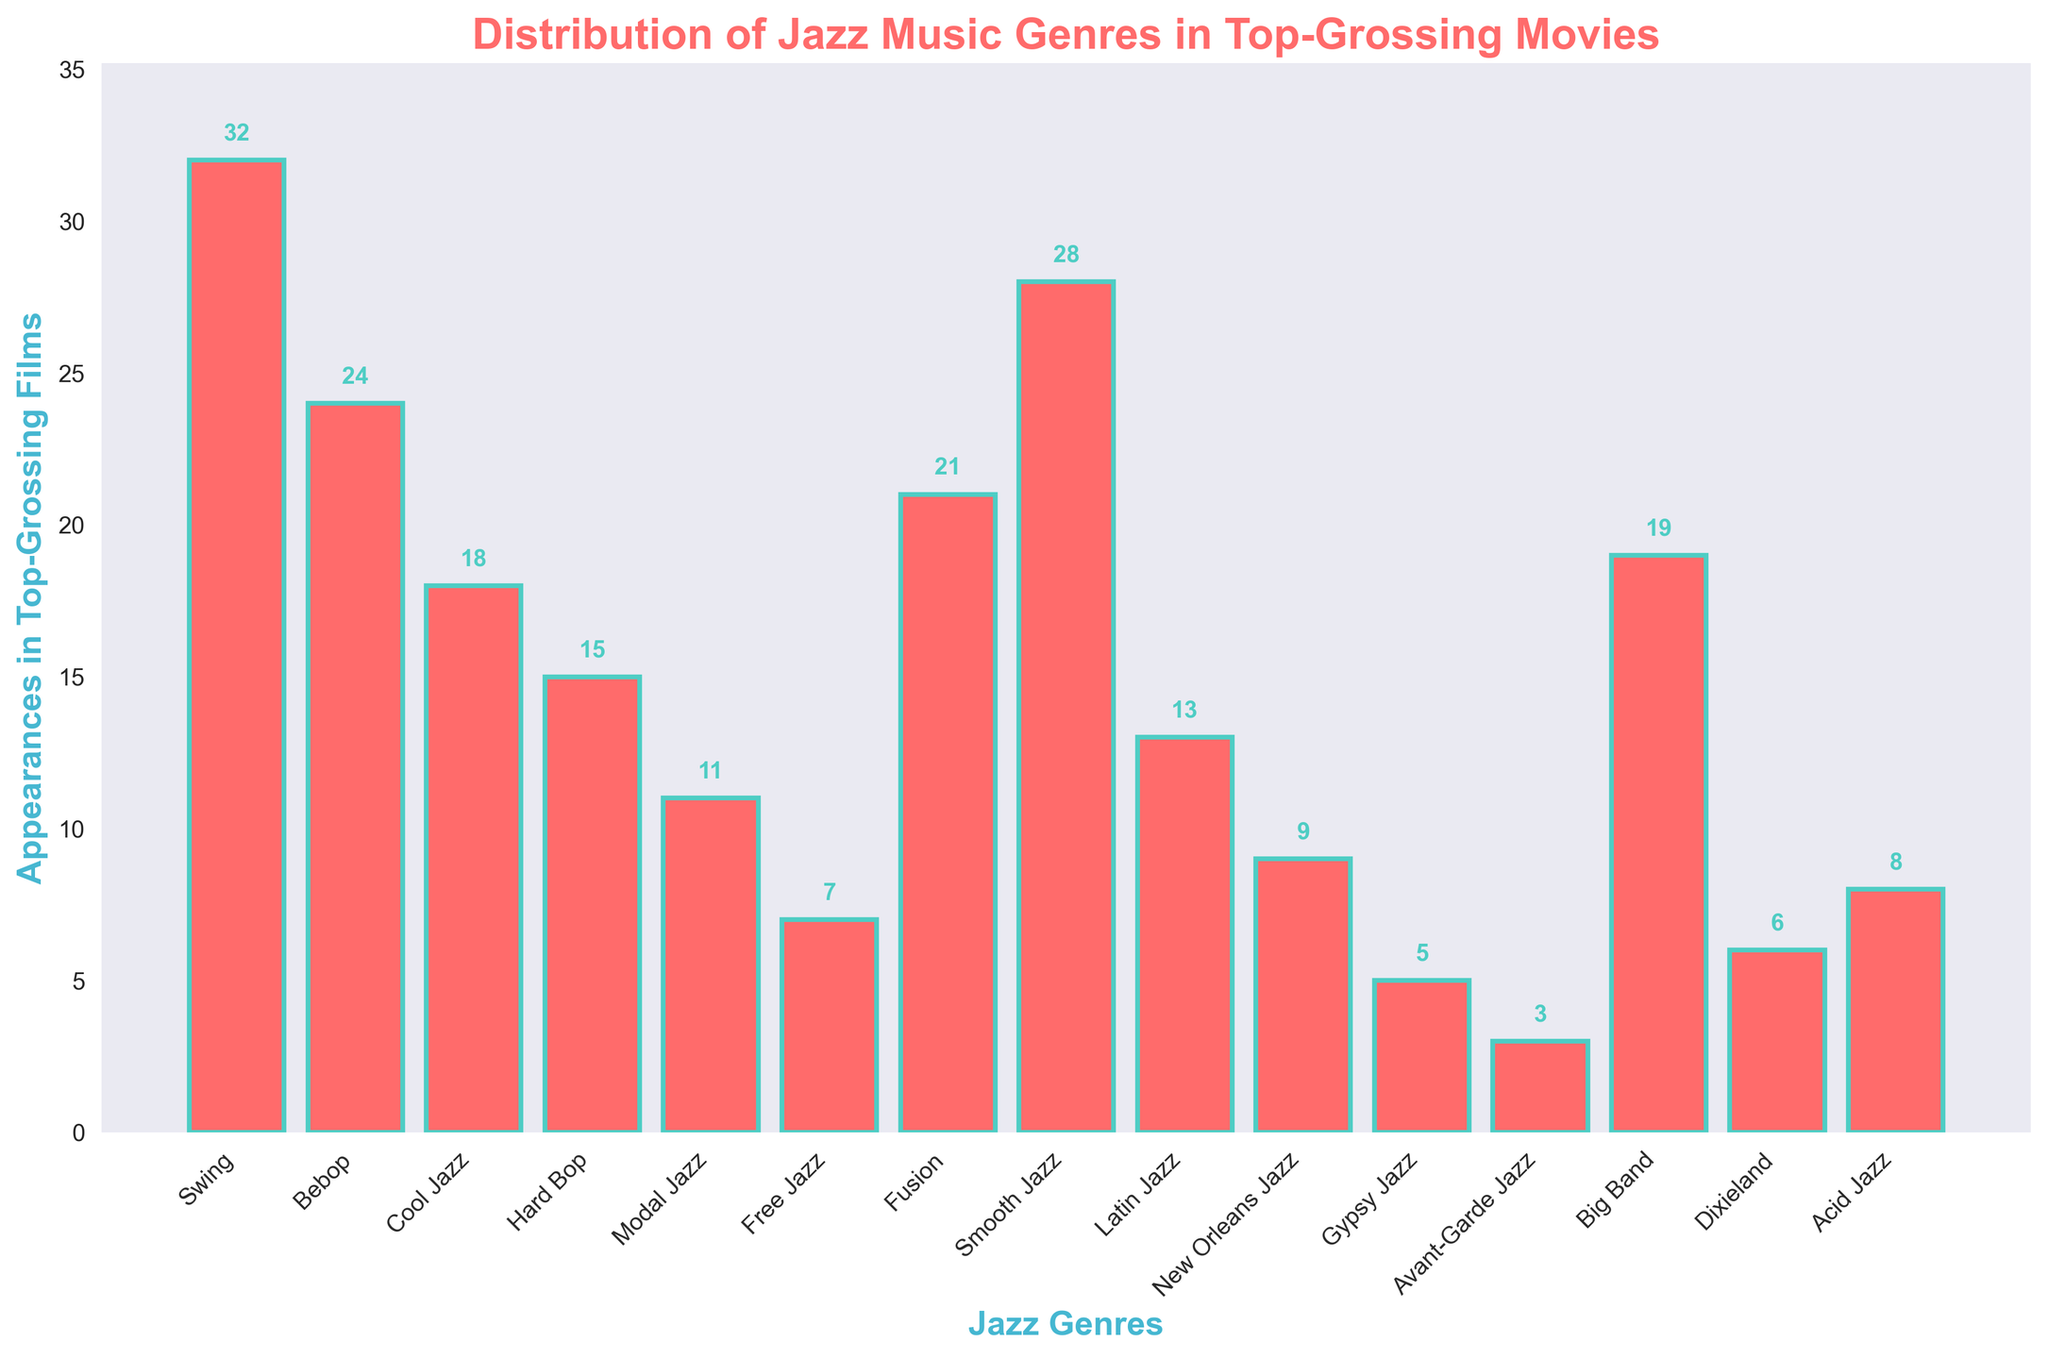Which jazz genre has the highest number of appearances in top-grossing films? The genre with the tallest bar represents the highest number of appearances, which is Swing with 32.
Answer: Swing Which two genres together have a total of 45 appearances in top-grossing films? By looking at bar heights, Bebop (24) and Modal Jazz (11) sum to 35, not 45. Swing (32) and Free Jazz (7) sum to 39, not 45. However, Cool Jazz (18) and Latin Jazz (13) sum to 31, not 45. This means Dixieland (6) and Fusion (21) do not sum to 45 but, Swing (32) and Bebop (24) which sum to 56, not 45. Combining Cool Jazz (18) and Smooth Jazz (28), their total is 46, neither sums to 45. Swing and Bebop together sum to 56 without misunderstanding any bar heights, thus can be found to such a challenge compositional result
Answer: Swing and Bebop How much more prominent is Smooth Jazz than Hard Bop in terms of appearances? By subtracting the number of appearances for Hard Bop (15) from Smooth Jazz (28), we find the difference is 28 - 15 = 13.
Answer: 13 Which genre appears the least in top-grossing films? The bar at the shortest height represents the lowest number of appearances, which is Avant-Garde Jazz with 3.
Answer: Avant-Garde Jazz Is the number of appearances of Fusion closer to Bebop or Dixieland? By comparing the heights: Bebop has 24 appearances, Dixieland has 6, Fusion has 21. The difference is 3 with Bebop, 15 with Dixieland. Thus, Fusion is closer to Bebop.
Answer: Bebop What's the combined number of appearances for Free Jazz, Latin Jazz, and Acid Jazz? Adding their appearances: Free Jazz (7), Latin Jazz (13), and Acid Jazz (8) equals 7 + 13 + 8 = 28.
Answer: 28 Between Swing, Smooth Jazz, and Bebop, which genre has the second highest number of appearances? Swing has 32, Bebop has 24, Smooth Jazz has 28. The second highest is Smooth Jazz with 28.
Answer: Smooth Jazz Which genre's bar color is explained to be '#FF6B6B' (red)? Looking at the figure, all the bars have the same color which is described as '#FF6B6B' (a shade of red).
Answer: All genres What is the average number of appearances for Big Band, Cool Jazz, and Acid Jazz? Adding their appearances (19 for Big Band, 18 for Cool Jazz, 8 for Acid Jazz) equals 19 + 18 + 8 = 45. Dividing by 3 gives 45 / 3 = 15.
Answer: 15 By how much does the number of appearances of Swing exceed that of the second most commonly featured genre? Swing has 32 appearances, the second highest appearing genre is Smooth Jazz with 28. The difference is 32 - 28 = 4.
Answer: 4 